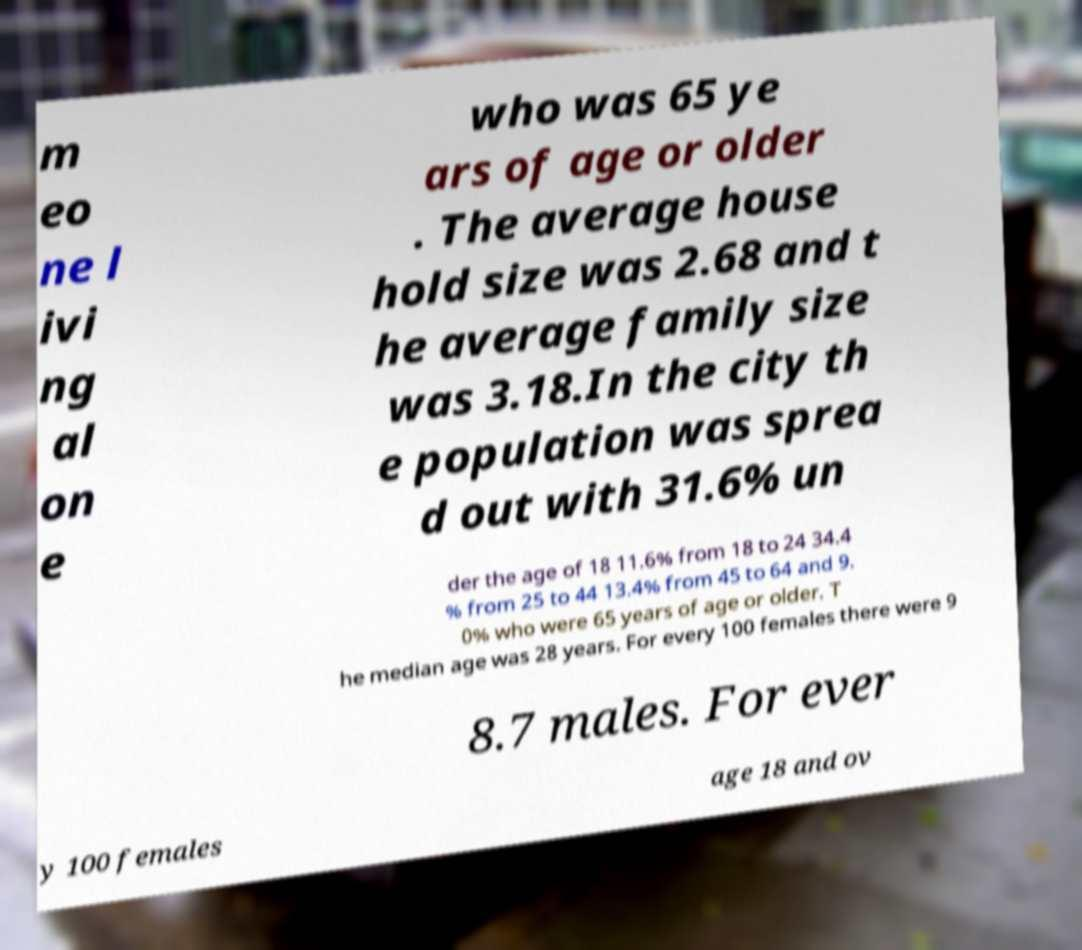For documentation purposes, I need the text within this image transcribed. Could you provide that? m eo ne l ivi ng al on e who was 65 ye ars of age or older . The average house hold size was 2.68 and t he average family size was 3.18.In the city th e population was sprea d out with 31.6% un der the age of 18 11.6% from 18 to 24 34.4 % from 25 to 44 13.4% from 45 to 64 and 9. 0% who were 65 years of age or older. T he median age was 28 years. For every 100 females there were 9 8.7 males. For ever y 100 females age 18 and ov 